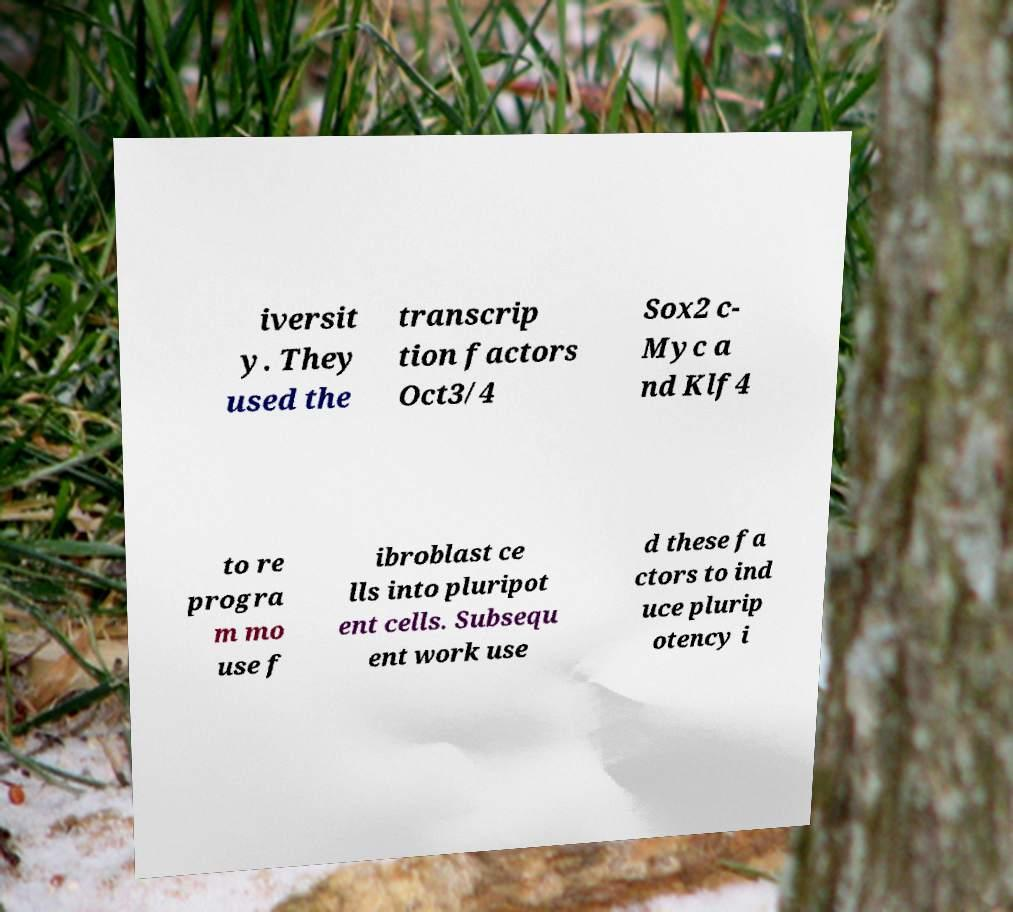Could you extract and type out the text from this image? iversit y. They used the transcrip tion factors Oct3/4 Sox2 c- Myc a nd Klf4 to re progra m mo use f ibroblast ce lls into pluripot ent cells. Subsequ ent work use d these fa ctors to ind uce plurip otency i 